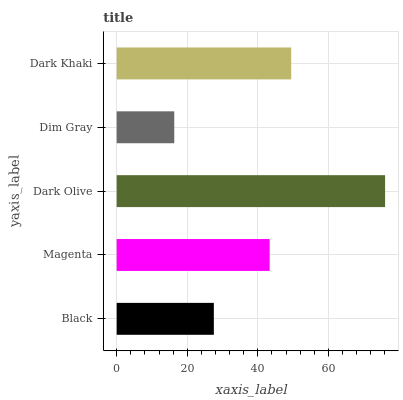Is Dim Gray the minimum?
Answer yes or no. Yes. Is Dark Olive the maximum?
Answer yes or no. Yes. Is Magenta the minimum?
Answer yes or no. No. Is Magenta the maximum?
Answer yes or no. No. Is Magenta greater than Black?
Answer yes or no. Yes. Is Black less than Magenta?
Answer yes or no. Yes. Is Black greater than Magenta?
Answer yes or no. No. Is Magenta less than Black?
Answer yes or no. No. Is Magenta the high median?
Answer yes or no. Yes. Is Magenta the low median?
Answer yes or no. Yes. Is Black the high median?
Answer yes or no. No. Is Dark Khaki the low median?
Answer yes or no. No. 